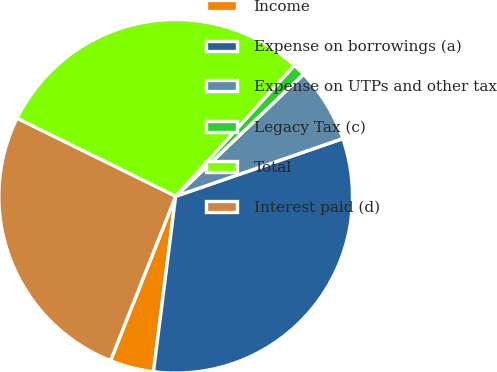Convert chart. <chart><loc_0><loc_0><loc_500><loc_500><pie_chart><fcel>Income<fcel>Expense on borrowings (a)<fcel>Expense on UTPs and other tax<fcel>Legacy Tax (c)<fcel>Total<fcel>Interest paid (d)<nl><fcel>4.0%<fcel>32.29%<fcel>6.84%<fcel>1.15%<fcel>29.44%<fcel>26.27%<nl></chart> 